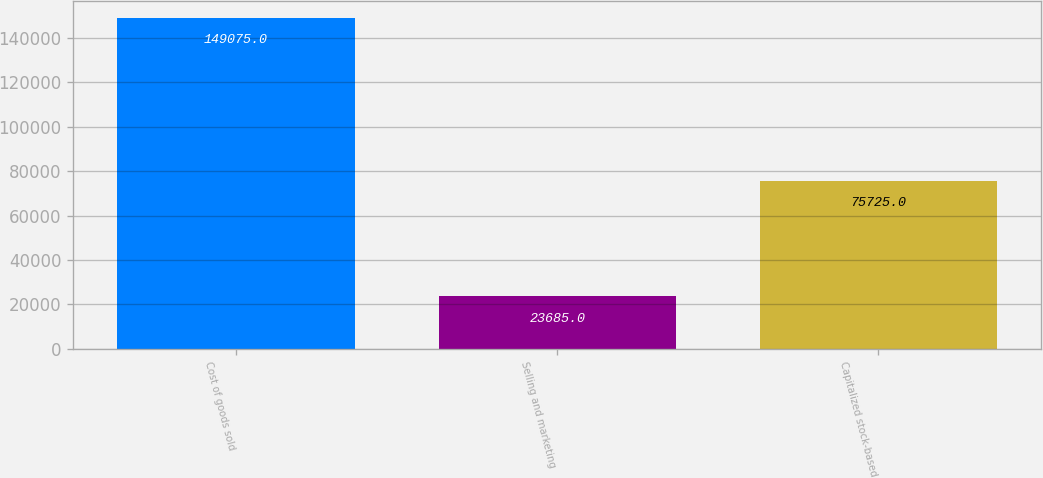<chart> <loc_0><loc_0><loc_500><loc_500><bar_chart><fcel>Cost of goods sold<fcel>Selling and marketing<fcel>Capitalized stock-based<nl><fcel>149075<fcel>23685<fcel>75725<nl></chart> 